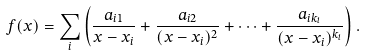<formula> <loc_0><loc_0><loc_500><loc_500>f ( x ) = \sum _ { i } \left ( { \frac { a _ { i 1 } } { x - x _ { i } } } + { \frac { a _ { i 2 } } { ( x - x _ { i } ) ^ { 2 } } } + \cdots + { \frac { a _ { i k _ { i } } } { ( x - x _ { i } ) ^ { k _ { i } } } } \right ) .</formula> 